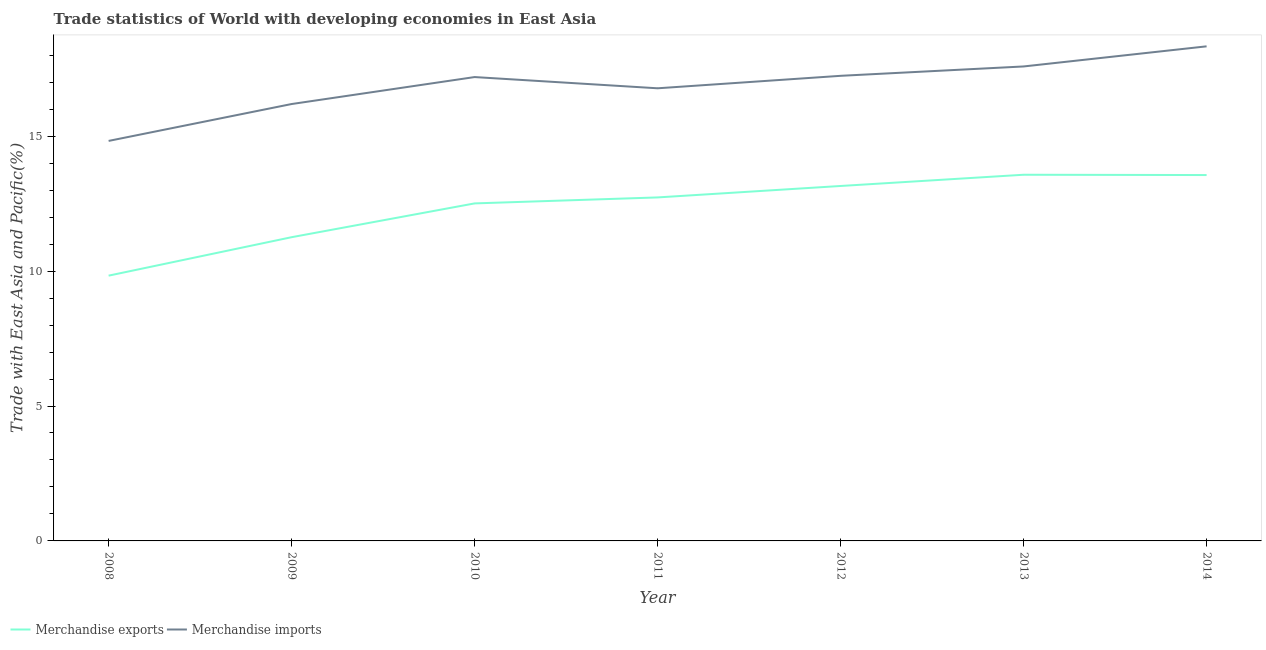What is the merchandise imports in 2010?
Offer a terse response. 17.19. Across all years, what is the maximum merchandise exports?
Your answer should be very brief. 13.57. Across all years, what is the minimum merchandise exports?
Offer a very short reply. 9.83. In which year was the merchandise exports minimum?
Make the answer very short. 2008. What is the total merchandise imports in the graph?
Offer a very short reply. 118.14. What is the difference between the merchandise exports in 2009 and that in 2014?
Make the answer very short. -2.3. What is the difference between the merchandise imports in 2012 and the merchandise exports in 2010?
Ensure brevity in your answer.  4.73. What is the average merchandise imports per year?
Your answer should be compact. 16.88. In the year 2010, what is the difference between the merchandise exports and merchandise imports?
Your answer should be compact. -4.68. In how many years, is the merchandise exports greater than 13 %?
Offer a very short reply. 3. What is the ratio of the merchandise imports in 2010 to that in 2012?
Provide a succinct answer. 1. Is the merchandise imports in 2010 less than that in 2011?
Offer a terse response. No. Is the difference between the merchandise imports in 2008 and 2011 greater than the difference between the merchandise exports in 2008 and 2011?
Offer a terse response. Yes. What is the difference between the highest and the second highest merchandise imports?
Give a very brief answer. 0.75. What is the difference between the highest and the lowest merchandise exports?
Provide a short and direct response. 3.74. Is the merchandise imports strictly greater than the merchandise exports over the years?
Offer a terse response. Yes. What is the difference between two consecutive major ticks on the Y-axis?
Provide a short and direct response. 5. Are the values on the major ticks of Y-axis written in scientific E-notation?
Ensure brevity in your answer.  No. Does the graph contain any zero values?
Offer a terse response. No. Does the graph contain grids?
Your answer should be very brief. No. Where does the legend appear in the graph?
Your response must be concise. Bottom left. How many legend labels are there?
Your answer should be very brief. 2. What is the title of the graph?
Keep it short and to the point. Trade statistics of World with developing economies in East Asia. What is the label or title of the Y-axis?
Your answer should be compact. Trade with East Asia and Pacific(%). What is the Trade with East Asia and Pacific(%) of Merchandise exports in 2008?
Provide a short and direct response. 9.83. What is the Trade with East Asia and Pacific(%) in Merchandise imports in 2008?
Your response must be concise. 14.83. What is the Trade with East Asia and Pacific(%) of Merchandise exports in 2009?
Your answer should be very brief. 11.26. What is the Trade with East Asia and Pacific(%) in Merchandise imports in 2009?
Your answer should be compact. 16.19. What is the Trade with East Asia and Pacific(%) of Merchandise exports in 2010?
Provide a succinct answer. 12.51. What is the Trade with East Asia and Pacific(%) of Merchandise imports in 2010?
Your answer should be compact. 17.19. What is the Trade with East Asia and Pacific(%) of Merchandise exports in 2011?
Offer a terse response. 12.73. What is the Trade with East Asia and Pacific(%) in Merchandise imports in 2011?
Keep it short and to the point. 16.78. What is the Trade with East Asia and Pacific(%) of Merchandise exports in 2012?
Provide a succinct answer. 13.16. What is the Trade with East Asia and Pacific(%) of Merchandise imports in 2012?
Keep it short and to the point. 17.24. What is the Trade with East Asia and Pacific(%) in Merchandise exports in 2013?
Give a very brief answer. 13.57. What is the Trade with East Asia and Pacific(%) in Merchandise imports in 2013?
Your answer should be very brief. 17.59. What is the Trade with East Asia and Pacific(%) in Merchandise exports in 2014?
Your response must be concise. 13.56. What is the Trade with East Asia and Pacific(%) in Merchandise imports in 2014?
Offer a very short reply. 18.33. Across all years, what is the maximum Trade with East Asia and Pacific(%) in Merchandise exports?
Offer a terse response. 13.57. Across all years, what is the maximum Trade with East Asia and Pacific(%) of Merchandise imports?
Offer a terse response. 18.33. Across all years, what is the minimum Trade with East Asia and Pacific(%) in Merchandise exports?
Provide a short and direct response. 9.83. Across all years, what is the minimum Trade with East Asia and Pacific(%) of Merchandise imports?
Give a very brief answer. 14.83. What is the total Trade with East Asia and Pacific(%) of Merchandise exports in the graph?
Give a very brief answer. 86.62. What is the total Trade with East Asia and Pacific(%) of Merchandise imports in the graph?
Your response must be concise. 118.14. What is the difference between the Trade with East Asia and Pacific(%) of Merchandise exports in 2008 and that in 2009?
Give a very brief answer. -1.43. What is the difference between the Trade with East Asia and Pacific(%) of Merchandise imports in 2008 and that in 2009?
Provide a succinct answer. -1.37. What is the difference between the Trade with East Asia and Pacific(%) in Merchandise exports in 2008 and that in 2010?
Offer a terse response. -2.68. What is the difference between the Trade with East Asia and Pacific(%) in Merchandise imports in 2008 and that in 2010?
Make the answer very short. -2.37. What is the difference between the Trade with East Asia and Pacific(%) of Merchandise exports in 2008 and that in 2011?
Your answer should be compact. -2.9. What is the difference between the Trade with East Asia and Pacific(%) of Merchandise imports in 2008 and that in 2011?
Offer a very short reply. -1.95. What is the difference between the Trade with East Asia and Pacific(%) of Merchandise exports in 2008 and that in 2012?
Provide a succinct answer. -3.32. What is the difference between the Trade with East Asia and Pacific(%) of Merchandise imports in 2008 and that in 2012?
Offer a very short reply. -2.41. What is the difference between the Trade with East Asia and Pacific(%) in Merchandise exports in 2008 and that in 2013?
Offer a terse response. -3.74. What is the difference between the Trade with East Asia and Pacific(%) of Merchandise imports in 2008 and that in 2013?
Offer a terse response. -2.76. What is the difference between the Trade with East Asia and Pacific(%) in Merchandise exports in 2008 and that in 2014?
Your answer should be compact. -3.73. What is the difference between the Trade with East Asia and Pacific(%) in Merchandise imports in 2008 and that in 2014?
Your answer should be very brief. -3.51. What is the difference between the Trade with East Asia and Pacific(%) in Merchandise exports in 2009 and that in 2010?
Ensure brevity in your answer.  -1.25. What is the difference between the Trade with East Asia and Pacific(%) of Merchandise imports in 2009 and that in 2010?
Keep it short and to the point. -1. What is the difference between the Trade with East Asia and Pacific(%) in Merchandise exports in 2009 and that in 2011?
Ensure brevity in your answer.  -1.47. What is the difference between the Trade with East Asia and Pacific(%) of Merchandise imports in 2009 and that in 2011?
Ensure brevity in your answer.  -0.58. What is the difference between the Trade with East Asia and Pacific(%) in Merchandise exports in 2009 and that in 2012?
Offer a terse response. -1.9. What is the difference between the Trade with East Asia and Pacific(%) of Merchandise imports in 2009 and that in 2012?
Offer a very short reply. -1.05. What is the difference between the Trade with East Asia and Pacific(%) of Merchandise exports in 2009 and that in 2013?
Provide a succinct answer. -2.31. What is the difference between the Trade with East Asia and Pacific(%) in Merchandise imports in 2009 and that in 2013?
Give a very brief answer. -1.39. What is the difference between the Trade with East Asia and Pacific(%) in Merchandise exports in 2009 and that in 2014?
Your answer should be very brief. -2.3. What is the difference between the Trade with East Asia and Pacific(%) of Merchandise imports in 2009 and that in 2014?
Your response must be concise. -2.14. What is the difference between the Trade with East Asia and Pacific(%) in Merchandise exports in 2010 and that in 2011?
Offer a very short reply. -0.22. What is the difference between the Trade with East Asia and Pacific(%) in Merchandise imports in 2010 and that in 2011?
Your response must be concise. 0.42. What is the difference between the Trade with East Asia and Pacific(%) in Merchandise exports in 2010 and that in 2012?
Keep it short and to the point. -0.65. What is the difference between the Trade with East Asia and Pacific(%) in Merchandise imports in 2010 and that in 2012?
Provide a succinct answer. -0.05. What is the difference between the Trade with East Asia and Pacific(%) of Merchandise exports in 2010 and that in 2013?
Provide a short and direct response. -1.06. What is the difference between the Trade with East Asia and Pacific(%) in Merchandise imports in 2010 and that in 2013?
Your answer should be compact. -0.39. What is the difference between the Trade with East Asia and Pacific(%) of Merchandise exports in 2010 and that in 2014?
Your answer should be very brief. -1.05. What is the difference between the Trade with East Asia and Pacific(%) in Merchandise imports in 2010 and that in 2014?
Provide a succinct answer. -1.14. What is the difference between the Trade with East Asia and Pacific(%) in Merchandise exports in 2011 and that in 2012?
Ensure brevity in your answer.  -0.42. What is the difference between the Trade with East Asia and Pacific(%) in Merchandise imports in 2011 and that in 2012?
Ensure brevity in your answer.  -0.46. What is the difference between the Trade with East Asia and Pacific(%) of Merchandise exports in 2011 and that in 2013?
Offer a very short reply. -0.84. What is the difference between the Trade with East Asia and Pacific(%) in Merchandise imports in 2011 and that in 2013?
Offer a terse response. -0.81. What is the difference between the Trade with East Asia and Pacific(%) of Merchandise exports in 2011 and that in 2014?
Offer a very short reply. -0.83. What is the difference between the Trade with East Asia and Pacific(%) in Merchandise imports in 2011 and that in 2014?
Offer a terse response. -1.55. What is the difference between the Trade with East Asia and Pacific(%) of Merchandise exports in 2012 and that in 2013?
Ensure brevity in your answer.  -0.42. What is the difference between the Trade with East Asia and Pacific(%) of Merchandise imports in 2012 and that in 2013?
Offer a terse response. -0.35. What is the difference between the Trade with East Asia and Pacific(%) of Merchandise exports in 2012 and that in 2014?
Keep it short and to the point. -0.41. What is the difference between the Trade with East Asia and Pacific(%) in Merchandise imports in 2012 and that in 2014?
Keep it short and to the point. -1.09. What is the difference between the Trade with East Asia and Pacific(%) of Merchandise exports in 2013 and that in 2014?
Keep it short and to the point. 0.01. What is the difference between the Trade with East Asia and Pacific(%) in Merchandise imports in 2013 and that in 2014?
Ensure brevity in your answer.  -0.75. What is the difference between the Trade with East Asia and Pacific(%) in Merchandise exports in 2008 and the Trade with East Asia and Pacific(%) in Merchandise imports in 2009?
Make the answer very short. -6.36. What is the difference between the Trade with East Asia and Pacific(%) in Merchandise exports in 2008 and the Trade with East Asia and Pacific(%) in Merchandise imports in 2010?
Give a very brief answer. -7.36. What is the difference between the Trade with East Asia and Pacific(%) of Merchandise exports in 2008 and the Trade with East Asia and Pacific(%) of Merchandise imports in 2011?
Ensure brevity in your answer.  -6.94. What is the difference between the Trade with East Asia and Pacific(%) of Merchandise exports in 2008 and the Trade with East Asia and Pacific(%) of Merchandise imports in 2012?
Your answer should be very brief. -7.41. What is the difference between the Trade with East Asia and Pacific(%) of Merchandise exports in 2008 and the Trade with East Asia and Pacific(%) of Merchandise imports in 2013?
Give a very brief answer. -7.75. What is the difference between the Trade with East Asia and Pacific(%) of Merchandise exports in 2008 and the Trade with East Asia and Pacific(%) of Merchandise imports in 2014?
Your answer should be compact. -8.5. What is the difference between the Trade with East Asia and Pacific(%) of Merchandise exports in 2009 and the Trade with East Asia and Pacific(%) of Merchandise imports in 2010?
Offer a very short reply. -5.94. What is the difference between the Trade with East Asia and Pacific(%) in Merchandise exports in 2009 and the Trade with East Asia and Pacific(%) in Merchandise imports in 2011?
Offer a terse response. -5.52. What is the difference between the Trade with East Asia and Pacific(%) of Merchandise exports in 2009 and the Trade with East Asia and Pacific(%) of Merchandise imports in 2012?
Provide a succinct answer. -5.98. What is the difference between the Trade with East Asia and Pacific(%) in Merchandise exports in 2009 and the Trade with East Asia and Pacific(%) in Merchandise imports in 2013?
Offer a very short reply. -6.33. What is the difference between the Trade with East Asia and Pacific(%) in Merchandise exports in 2009 and the Trade with East Asia and Pacific(%) in Merchandise imports in 2014?
Keep it short and to the point. -7.07. What is the difference between the Trade with East Asia and Pacific(%) in Merchandise exports in 2010 and the Trade with East Asia and Pacific(%) in Merchandise imports in 2011?
Give a very brief answer. -4.27. What is the difference between the Trade with East Asia and Pacific(%) of Merchandise exports in 2010 and the Trade with East Asia and Pacific(%) of Merchandise imports in 2012?
Offer a terse response. -4.73. What is the difference between the Trade with East Asia and Pacific(%) of Merchandise exports in 2010 and the Trade with East Asia and Pacific(%) of Merchandise imports in 2013?
Your response must be concise. -5.08. What is the difference between the Trade with East Asia and Pacific(%) in Merchandise exports in 2010 and the Trade with East Asia and Pacific(%) in Merchandise imports in 2014?
Your answer should be compact. -5.82. What is the difference between the Trade with East Asia and Pacific(%) in Merchandise exports in 2011 and the Trade with East Asia and Pacific(%) in Merchandise imports in 2012?
Make the answer very short. -4.51. What is the difference between the Trade with East Asia and Pacific(%) of Merchandise exports in 2011 and the Trade with East Asia and Pacific(%) of Merchandise imports in 2013?
Your answer should be compact. -4.85. What is the difference between the Trade with East Asia and Pacific(%) of Merchandise exports in 2011 and the Trade with East Asia and Pacific(%) of Merchandise imports in 2014?
Provide a succinct answer. -5.6. What is the difference between the Trade with East Asia and Pacific(%) in Merchandise exports in 2012 and the Trade with East Asia and Pacific(%) in Merchandise imports in 2013?
Provide a short and direct response. -4.43. What is the difference between the Trade with East Asia and Pacific(%) in Merchandise exports in 2012 and the Trade with East Asia and Pacific(%) in Merchandise imports in 2014?
Your answer should be very brief. -5.18. What is the difference between the Trade with East Asia and Pacific(%) in Merchandise exports in 2013 and the Trade with East Asia and Pacific(%) in Merchandise imports in 2014?
Offer a terse response. -4.76. What is the average Trade with East Asia and Pacific(%) of Merchandise exports per year?
Ensure brevity in your answer.  12.37. What is the average Trade with East Asia and Pacific(%) in Merchandise imports per year?
Your answer should be compact. 16.88. In the year 2008, what is the difference between the Trade with East Asia and Pacific(%) of Merchandise exports and Trade with East Asia and Pacific(%) of Merchandise imports?
Ensure brevity in your answer.  -4.99. In the year 2009, what is the difference between the Trade with East Asia and Pacific(%) of Merchandise exports and Trade with East Asia and Pacific(%) of Merchandise imports?
Offer a very short reply. -4.94. In the year 2010, what is the difference between the Trade with East Asia and Pacific(%) of Merchandise exports and Trade with East Asia and Pacific(%) of Merchandise imports?
Offer a very short reply. -4.68. In the year 2011, what is the difference between the Trade with East Asia and Pacific(%) in Merchandise exports and Trade with East Asia and Pacific(%) in Merchandise imports?
Ensure brevity in your answer.  -4.05. In the year 2012, what is the difference between the Trade with East Asia and Pacific(%) in Merchandise exports and Trade with East Asia and Pacific(%) in Merchandise imports?
Give a very brief answer. -4.08. In the year 2013, what is the difference between the Trade with East Asia and Pacific(%) in Merchandise exports and Trade with East Asia and Pacific(%) in Merchandise imports?
Provide a succinct answer. -4.01. In the year 2014, what is the difference between the Trade with East Asia and Pacific(%) of Merchandise exports and Trade with East Asia and Pacific(%) of Merchandise imports?
Your answer should be very brief. -4.77. What is the ratio of the Trade with East Asia and Pacific(%) in Merchandise exports in 2008 to that in 2009?
Provide a short and direct response. 0.87. What is the ratio of the Trade with East Asia and Pacific(%) of Merchandise imports in 2008 to that in 2009?
Make the answer very short. 0.92. What is the ratio of the Trade with East Asia and Pacific(%) in Merchandise exports in 2008 to that in 2010?
Provide a succinct answer. 0.79. What is the ratio of the Trade with East Asia and Pacific(%) in Merchandise imports in 2008 to that in 2010?
Provide a short and direct response. 0.86. What is the ratio of the Trade with East Asia and Pacific(%) in Merchandise exports in 2008 to that in 2011?
Offer a terse response. 0.77. What is the ratio of the Trade with East Asia and Pacific(%) of Merchandise imports in 2008 to that in 2011?
Provide a short and direct response. 0.88. What is the ratio of the Trade with East Asia and Pacific(%) in Merchandise exports in 2008 to that in 2012?
Provide a succinct answer. 0.75. What is the ratio of the Trade with East Asia and Pacific(%) of Merchandise imports in 2008 to that in 2012?
Offer a very short reply. 0.86. What is the ratio of the Trade with East Asia and Pacific(%) in Merchandise exports in 2008 to that in 2013?
Provide a succinct answer. 0.72. What is the ratio of the Trade with East Asia and Pacific(%) of Merchandise imports in 2008 to that in 2013?
Offer a terse response. 0.84. What is the ratio of the Trade with East Asia and Pacific(%) of Merchandise exports in 2008 to that in 2014?
Offer a very short reply. 0.72. What is the ratio of the Trade with East Asia and Pacific(%) in Merchandise imports in 2008 to that in 2014?
Offer a terse response. 0.81. What is the ratio of the Trade with East Asia and Pacific(%) of Merchandise exports in 2009 to that in 2010?
Make the answer very short. 0.9. What is the ratio of the Trade with East Asia and Pacific(%) in Merchandise imports in 2009 to that in 2010?
Provide a short and direct response. 0.94. What is the ratio of the Trade with East Asia and Pacific(%) of Merchandise exports in 2009 to that in 2011?
Your answer should be very brief. 0.88. What is the ratio of the Trade with East Asia and Pacific(%) in Merchandise imports in 2009 to that in 2011?
Your response must be concise. 0.97. What is the ratio of the Trade with East Asia and Pacific(%) of Merchandise exports in 2009 to that in 2012?
Make the answer very short. 0.86. What is the ratio of the Trade with East Asia and Pacific(%) of Merchandise imports in 2009 to that in 2012?
Keep it short and to the point. 0.94. What is the ratio of the Trade with East Asia and Pacific(%) of Merchandise exports in 2009 to that in 2013?
Your answer should be very brief. 0.83. What is the ratio of the Trade with East Asia and Pacific(%) in Merchandise imports in 2009 to that in 2013?
Give a very brief answer. 0.92. What is the ratio of the Trade with East Asia and Pacific(%) in Merchandise exports in 2009 to that in 2014?
Keep it short and to the point. 0.83. What is the ratio of the Trade with East Asia and Pacific(%) of Merchandise imports in 2009 to that in 2014?
Your answer should be very brief. 0.88. What is the ratio of the Trade with East Asia and Pacific(%) of Merchandise exports in 2010 to that in 2011?
Offer a very short reply. 0.98. What is the ratio of the Trade with East Asia and Pacific(%) in Merchandise imports in 2010 to that in 2011?
Offer a very short reply. 1.02. What is the ratio of the Trade with East Asia and Pacific(%) in Merchandise exports in 2010 to that in 2012?
Keep it short and to the point. 0.95. What is the ratio of the Trade with East Asia and Pacific(%) of Merchandise imports in 2010 to that in 2012?
Make the answer very short. 1. What is the ratio of the Trade with East Asia and Pacific(%) of Merchandise exports in 2010 to that in 2013?
Provide a short and direct response. 0.92. What is the ratio of the Trade with East Asia and Pacific(%) of Merchandise imports in 2010 to that in 2013?
Your answer should be very brief. 0.98. What is the ratio of the Trade with East Asia and Pacific(%) of Merchandise exports in 2010 to that in 2014?
Ensure brevity in your answer.  0.92. What is the ratio of the Trade with East Asia and Pacific(%) of Merchandise imports in 2010 to that in 2014?
Make the answer very short. 0.94. What is the ratio of the Trade with East Asia and Pacific(%) in Merchandise imports in 2011 to that in 2012?
Give a very brief answer. 0.97. What is the ratio of the Trade with East Asia and Pacific(%) in Merchandise exports in 2011 to that in 2013?
Offer a very short reply. 0.94. What is the ratio of the Trade with East Asia and Pacific(%) of Merchandise imports in 2011 to that in 2013?
Provide a succinct answer. 0.95. What is the ratio of the Trade with East Asia and Pacific(%) in Merchandise exports in 2011 to that in 2014?
Provide a short and direct response. 0.94. What is the ratio of the Trade with East Asia and Pacific(%) in Merchandise imports in 2011 to that in 2014?
Your response must be concise. 0.92. What is the ratio of the Trade with East Asia and Pacific(%) in Merchandise exports in 2012 to that in 2013?
Offer a very short reply. 0.97. What is the ratio of the Trade with East Asia and Pacific(%) in Merchandise imports in 2012 to that in 2013?
Keep it short and to the point. 0.98. What is the ratio of the Trade with East Asia and Pacific(%) of Merchandise exports in 2012 to that in 2014?
Make the answer very short. 0.97. What is the ratio of the Trade with East Asia and Pacific(%) in Merchandise imports in 2012 to that in 2014?
Your answer should be compact. 0.94. What is the ratio of the Trade with East Asia and Pacific(%) of Merchandise imports in 2013 to that in 2014?
Your answer should be very brief. 0.96. What is the difference between the highest and the second highest Trade with East Asia and Pacific(%) of Merchandise exports?
Your response must be concise. 0.01. What is the difference between the highest and the second highest Trade with East Asia and Pacific(%) of Merchandise imports?
Provide a short and direct response. 0.75. What is the difference between the highest and the lowest Trade with East Asia and Pacific(%) in Merchandise exports?
Your answer should be compact. 3.74. What is the difference between the highest and the lowest Trade with East Asia and Pacific(%) in Merchandise imports?
Offer a very short reply. 3.51. 